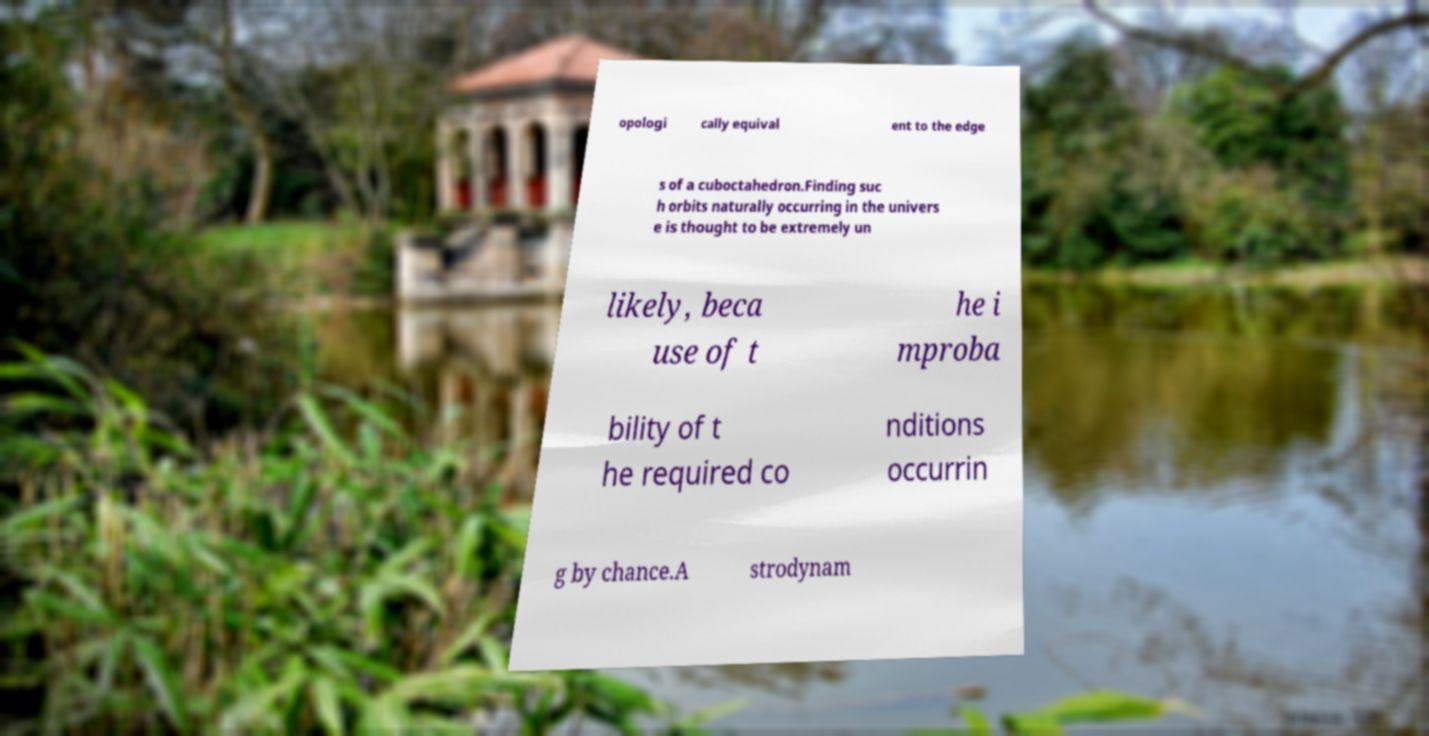For documentation purposes, I need the text within this image transcribed. Could you provide that? opologi cally equival ent to the edge s of a cuboctahedron.Finding suc h orbits naturally occurring in the univers e is thought to be extremely un likely, beca use of t he i mproba bility of t he required co nditions occurrin g by chance.A strodynam 